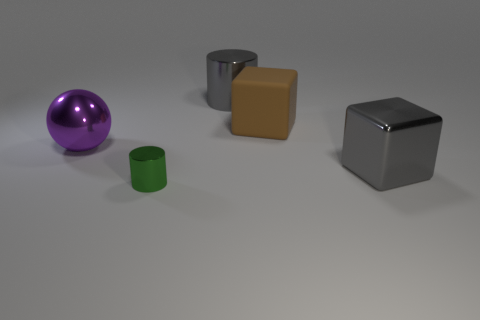What material is the large purple sphere?
Your response must be concise. Metal. What number of other rubber things are the same shape as the large rubber thing?
Ensure brevity in your answer.  0. There is a cylinder that is the same color as the big metallic block; what is its material?
Your response must be concise. Metal. Are there any other things that have the same shape as the purple thing?
Keep it short and to the point. No. What is the color of the block in front of the large object on the left side of the cylinder that is in front of the large gray metal block?
Ensure brevity in your answer.  Gray. How many small objects are either purple metal things or brown matte objects?
Offer a terse response. 0. Is the number of big rubber blocks behind the large brown block the same as the number of rubber objects?
Ensure brevity in your answer.  No. Are there any small metallic objects to the right of the large ball?
Offer a very short reply. Yes. What number of matte objects are large red cubes or large purple things?
Keep it short and to the point. 0. There is a tiny green metallic thing; what number of big cylinders are behind it?
Offer a terse response. 1. 